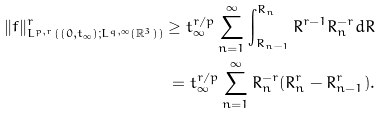Convert formula to latex. <formula><loc_0><loc_0><loc_500><loc_500>\| f \| ^ { r } _ { L ^ { p , r } ( ( 0 , t _ { \infty } ) ; L ^ { q , \infty } ( \mathbb { R } ^ { 3 } ) ) } \geq t _ { \infty } ^ { r / p } \sum _ { n = 1 } ^ { \infty } \int _ { R _ { n - 1 } } ^ { R _ { n } } R ^ { r - 1 } R _ { n } ^ { - r } d R \\ = t _ { \infty } ^ { r / p } \sum _ { n = 1 } ^ { \infty } R _ { n } ^ { - r } ( R _ { n } ^ { r } - R _ { n - 1 } ^ { r } ) .</formula> 